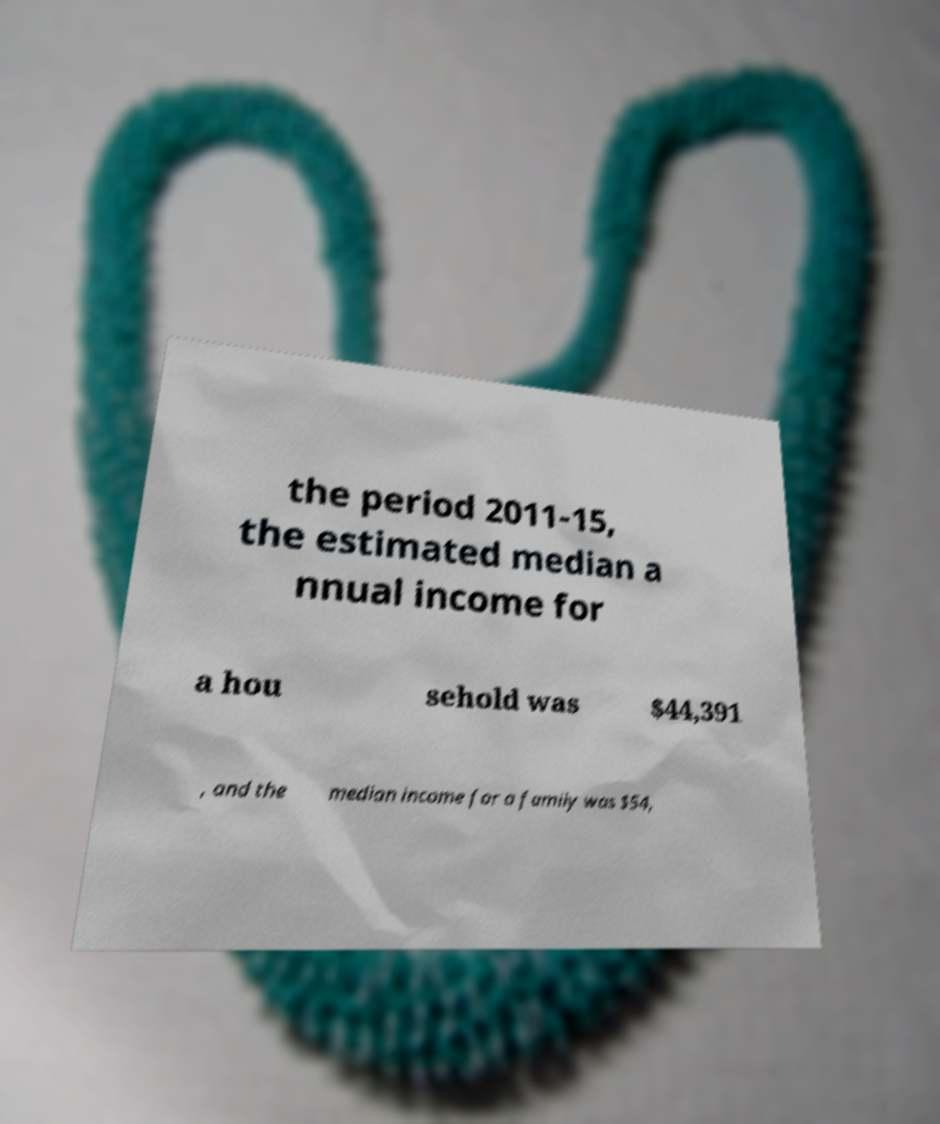I need the written content from this picture converted into text. Can you do that? the period 2011-15, the estimated median a nnual income for a hou sehold was $44,391 , and the median income for a family was $54, 